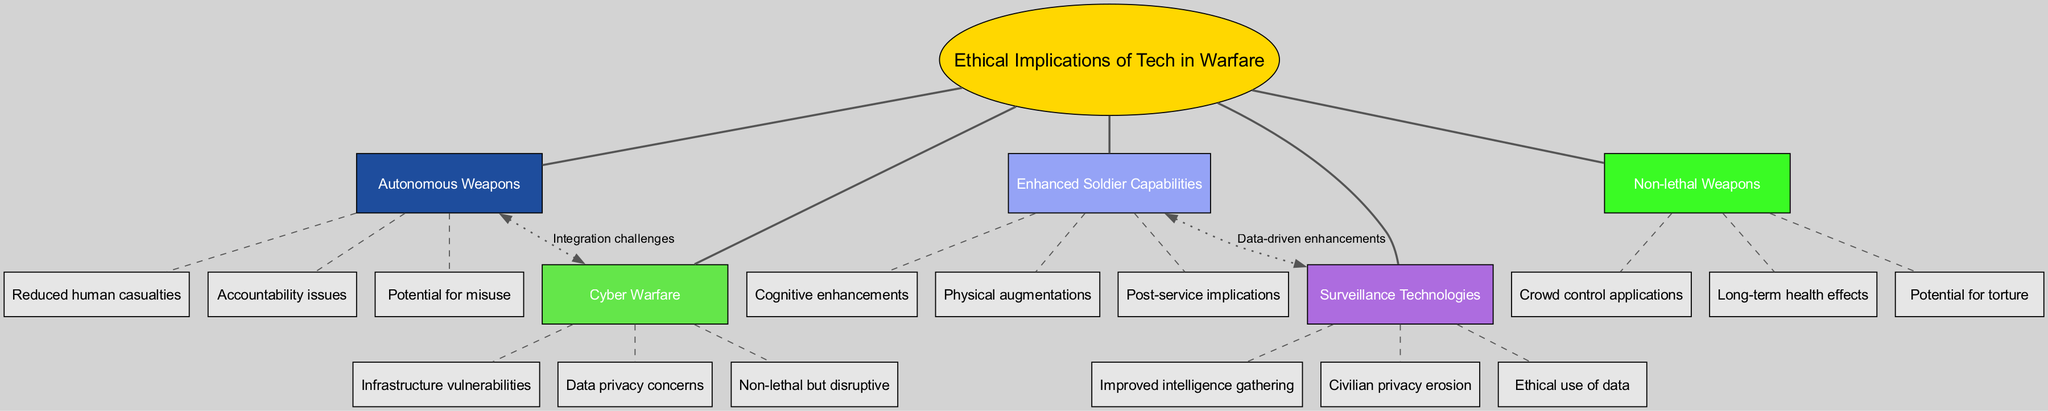What is the central theme of the diagram? The central theme is explicitly stated in the diagram's center node, which is "Ethical Implications of Tech in Warfare". This node is connected to all the main branches that explore various aspects of this theme.
Answer: Ethical Implications of Tech in Warfare How many main branches are present in the diagram? By counting the main branches listed, we find there are five distinct branches: Autonomous Weapons, Cyber Warfare, Enhanced Soldier Capabilities, Surveillance Technologies, and Non-lethal Weapons.
Answer: 5 What is one potential misuse related to autonomous weapons? The diagram lists "Potential for misuse" as one of the sub-branches under Autonomous Weapons, highlighting ethical concerns about how these weapons could be used inappropriately.
Answer: Potential for misuse Which branch connects enhanced soldier capabilities to surveillance technologies? The connection between these two branches is indicated in the diagram, specifically labeled as "Data-driven enhancements", showing a direct relationship between enhanced capabilities and the use of surveillance.
Answer: Data-driven enhancements What are the sub-branches under the Cyber Warfare main branch? The diagram outlines three specific sub-branches under Cyber Warfare: "Infrastructure vulnerabilities", "Data privacy concerns", and "Non-lethal but disruptive". These sub-branches explore various ethical implications of cyber warfare.
Answer: Infrastructure vulnerabilities, Data privacy concerns, Non-lethal but disruptive What connection is labeled "Integration challenges"? In the diagram, this connection is between the Autonomous Weapons branch and the Cyber Warfare branch, indicating concerns about how these two technological areas could be integrated within military operations.
Answer: Integration challenges What is the focus of the sub-branch "Cognitive enhancements"? This sub-branch under Enhanced Soldier Capabilities is concerned with the ethical implications surrounding the enhancement of soldiers' mental capacities, which reflects on the consequences of such advancements in warfare.
Answer: Cognitive enhancements How many sub-branches does the Non-lethal Weapons branch have? The Non-lethal Weapons branch consists of three listed sub-branches: "Crowd control applications", "Long-term health effects", and "Potential for torture", indicating the various ethical concerns regarding non-lethal technology.
Answer: 3 What is a key ethical concern regarding surveillance technologies? The diagram specifies "Civilian privacy erosion" as a critical ethical concern, showcasing the potential impact of surveillance innovations on personal privacy.
Answer: Civilian privacy erosion 